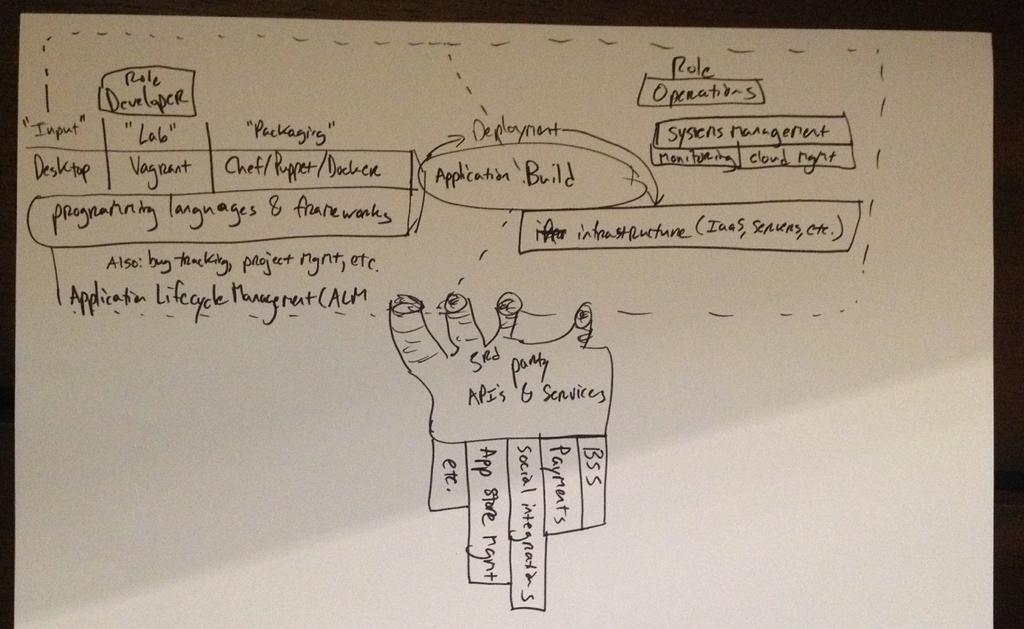In one or two sentences, can you explain what this image depicts? In this picture I see a white color thing on which there is something written. 